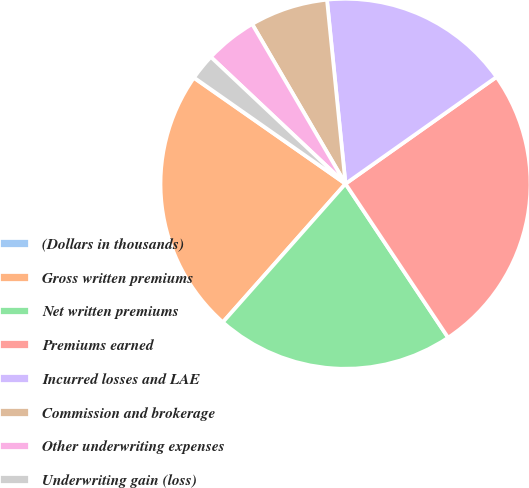Convert chart to OTSL. <chart><loc_0><loc_0><loc_500><loc_500><pie_chart><fcel>(Dollars in thousands)<fcel>Gross written premiums<fcel>Net written premiums<fcel>Premiums earned<fcel>Incurred losses and LAE<fcel>Commission and brokerage<fcel>Other underwriting expenses<fcel>Underwriting gain (loss)<nl><fcel>0.03%<fcel>23.16%<fcel>20.9%<fcel>25.43%<fcel>16.8%<fcel>6.82%<fcel>4.56%<fcel>2.29%<nl></chart> 